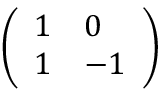<formula> <loc_0><loc_0><loc_500><loc_500>\left ( \begin{array} { l l } { 1 } & { 0 } \\ { 1 } & { - 1 } \end{array} \right )</formula> 